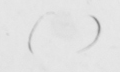Please provide the text content of this handwritten line. (   ) 